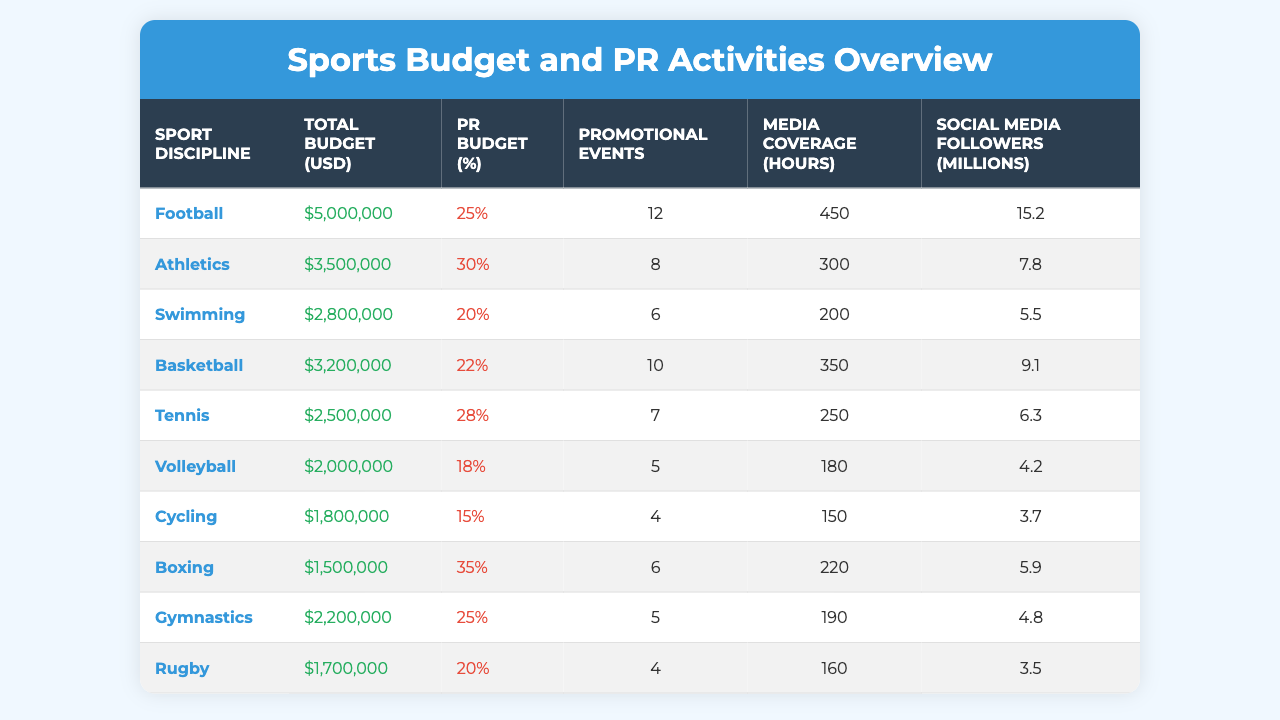What is the total budget allocated for Football? According to the table, the total budget for Football is listed under the "Total Budget (USD)" column. It shows an amount of $5,000,000.
Answer: $5,000,000 Which sport has the highest percentage of PR budget? Looking at the "PR Budget (%)" column, Boxing has the highest percentage at 35%.
Answer: 35% How many promotional events were conducted for Athletics? The table specifies that Athletics had 8 promotional events, found in the "Promotional Events" column next to Athletics.
Answer: 8 What is the average PR budget percentage across all sports disciplines listed? To find the average PR budget percentage, first sum the percentages: (25 + 30 + 20 + 22 + 28 + 18 + 15 + 35 + 25 + 20) =  25, and then divide by the number of sports (10), so the average is 25/10 = 25%.
Answer: 25% True or False: The media coverage for Volleyball is greater than 200 hours. The table shows that Volleyball has 180 hours of media coverage, which is less than 200. Therefore, the statement is false.
Answer: False What sport discipline has the least number of social media followers? By checking the "Social Media Followers (millions)" column, Cycling has the least number of followers with 3.7 million.
Answer: Cycling Which sport has more promotional events: Basketball or Swimming? Swimming has 6 promotional events, while Basketball has 10. Comparing these values, Basketball has more promotional events than Swimming.
Answer: Basketball If we add the total budgets for Tennis and Rugby, what is the total? Tennis has a budget of $2,500,000 and Rugby has $1,700,000. By adding these amounts ($2,500,000 + $1,700,000), we get $4,200,000 as the total budget for both sports.
Answer: $4,200,000 Which sport has the highest number of media coverage hours? The media coverage hours are highest for Football at 450 hours, as stated in the "Media Coverage (hours)" column.
Answer: Football If you were to rank the sports based on social media followers, which sport would be in the second position? The social media followers are ranked as follows: Football (15.2), Basketball (9.1), Athletics (7.8), Tennis (6.3), Swimming (5.5), Boxing (5.9), Gymnastics (4.8), Volleyball (4.2), Rugby (3.5), and Cycling (3.7). The second position goes to Basketball.
Answer: Basketball 